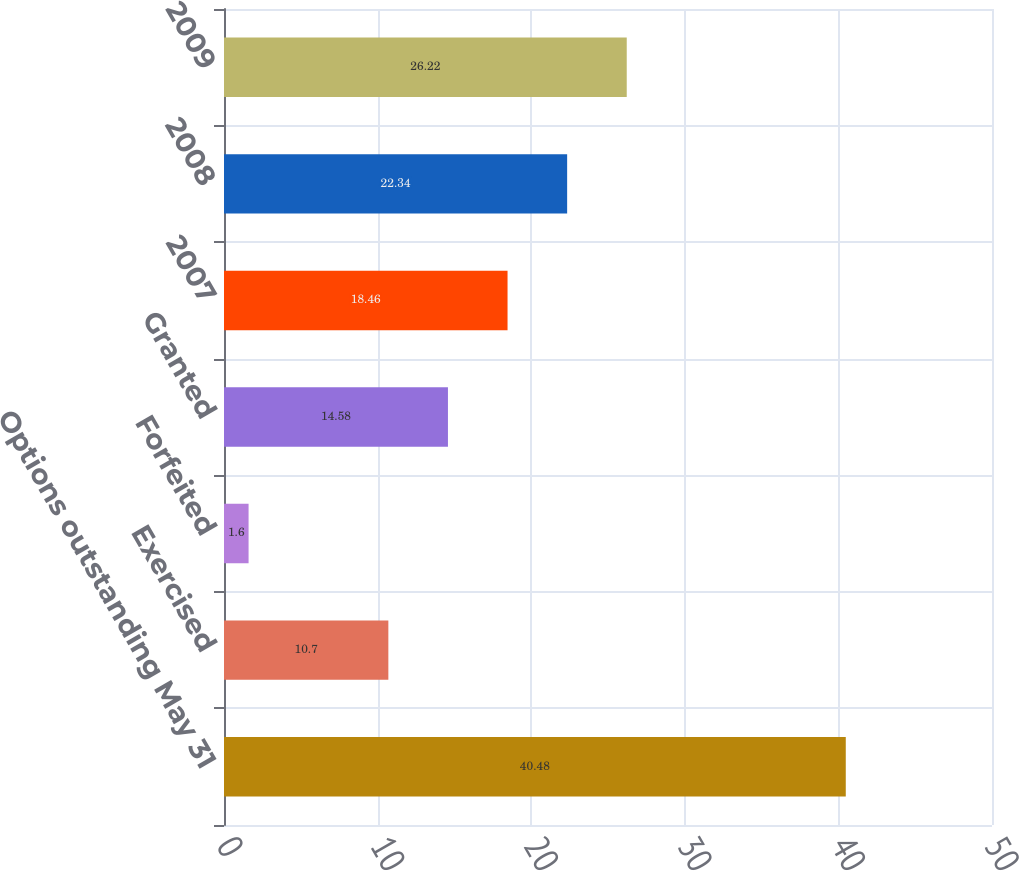Convert chart. <chart><loc_0><loc_0><loc_500><loc_500><bar_chart><fcel>Options outstanding May 31<fcel>Exercised<fcel>Forfeited<fcel>Granted<fcel>2007<fcel>2008<fcel>2009<nl><fcel>40.48<fcel>10.7<fcel>1.6<fcel>14.58<fcel>18.46<fcel>22.34<fcel>26.22<nl></chart> 